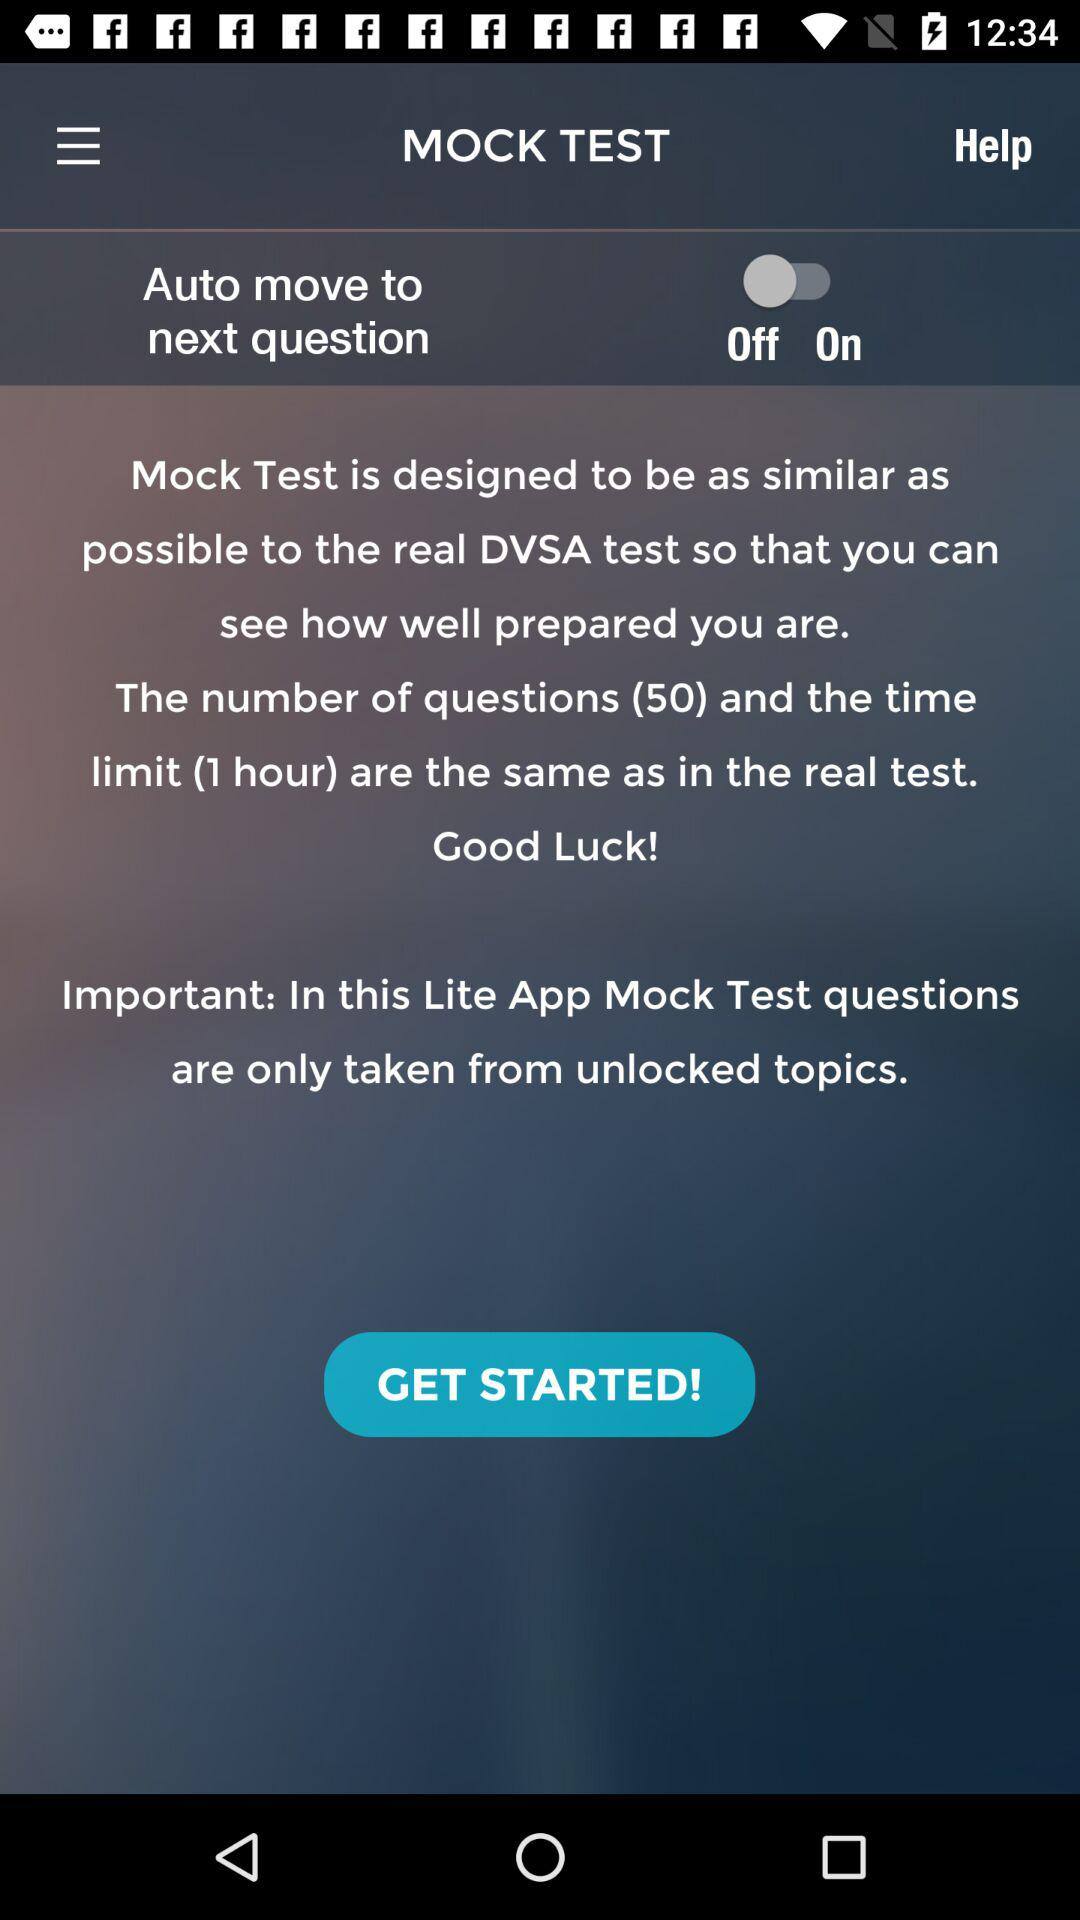What is the status of "Auto move to next question"? The status is "off". 